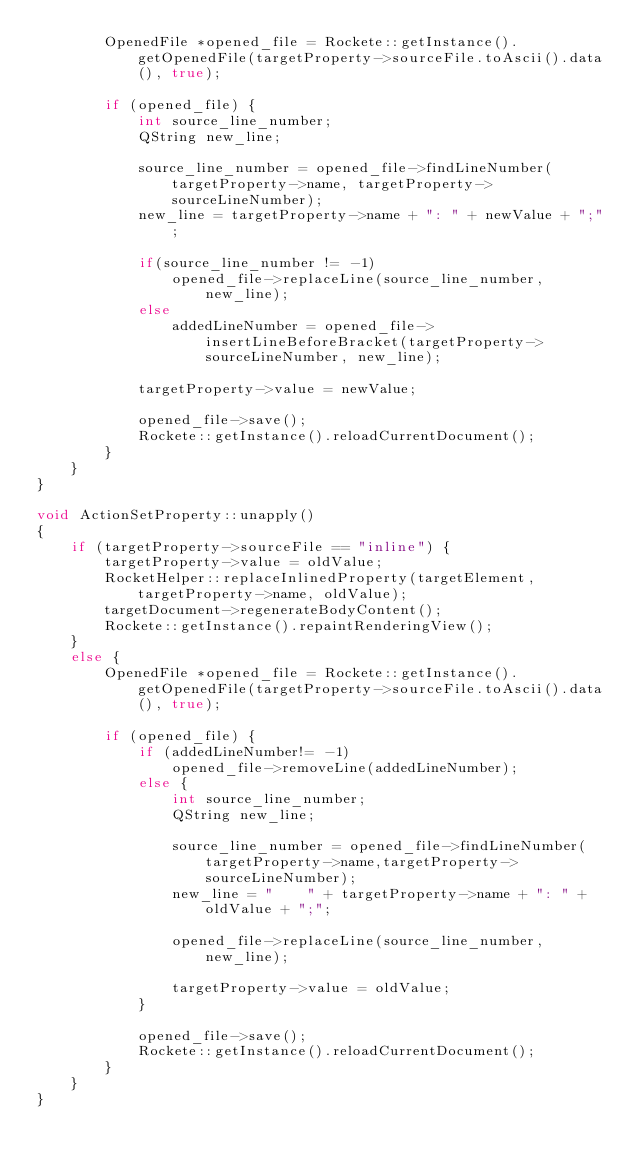<code> <loc_0><loc_0><loc_500><loc_500><_C++_>        OpenedFile *opened_file = Rockete::getInstance().getOpenedFile(targetProperty->sourceFile.toAscii().data(), true);

        if (opened_file) {
            int source_line_number;
            QString new_line;

            source_line_number = opened_file->findLineNumber(targetProperty->name, targetProperty->sourceLineNumber);
            new_line = targetProperty->name + ": " + newValue + ";";

            if(source_line_number != -1)
                opened_file->replaceLine(source_line_number, new_line);
            else
                addedLineNumber = opened_file->insertLineBeforeBracket(targetProperty->sourceLineNumber, new_line);

            targetProperty->value = newValue;

            opened_file->save();
            Rockete::getInstance().reloadCurrentDocument();
        }
    }
}

void ActionSetProperty::unapply()
{
    if (targetProperty->sourceFile == "inline") {
        targetProperty->value = oldValue;
        RocketHelper::replaceInlinedProperty(targetElement,targetProperty->name, oldValue);
        targetDocument->regenerateBodyContent();
        Rockete::getInstance().repaintRenderingView();
    }
    else {
        OpenedFile *opened_file = Rockete::getInstance().getOpenedFile(targetProperty->sourceFile.toAscii().data(), true);

        if (opened_file) {
            if (addedLineNumber!= -1)
                opened_file->removeLine(addedLineNumber);
            else {
                int source_line_number;
                QString new_line;

                source_line_number = opened_file->findLineNumber(targetProperty->name,targetProperty->sourceLineNumber);
                new_line = "    " + targetProperty->name + ": " + oldValue + ";";

                opened_file->replaceLine(source_line_number, new_line);

                targetProperty->value = oldValue;
            }

            opened_file->save();
            Rockete::getInstance().reloadCurrentDocument();
        }
    }
}
</code> 